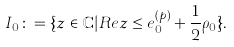<formula> <loc_0><loc_0><loc_500><loc_500>I _ { 0 } \colon = \{ z \in \mathbb { C } | R e z \leq e ^ { ( p ) } _ { 0 } + \frac { 1 } { 2 } \rho _ { 0 } \} .</formula> 